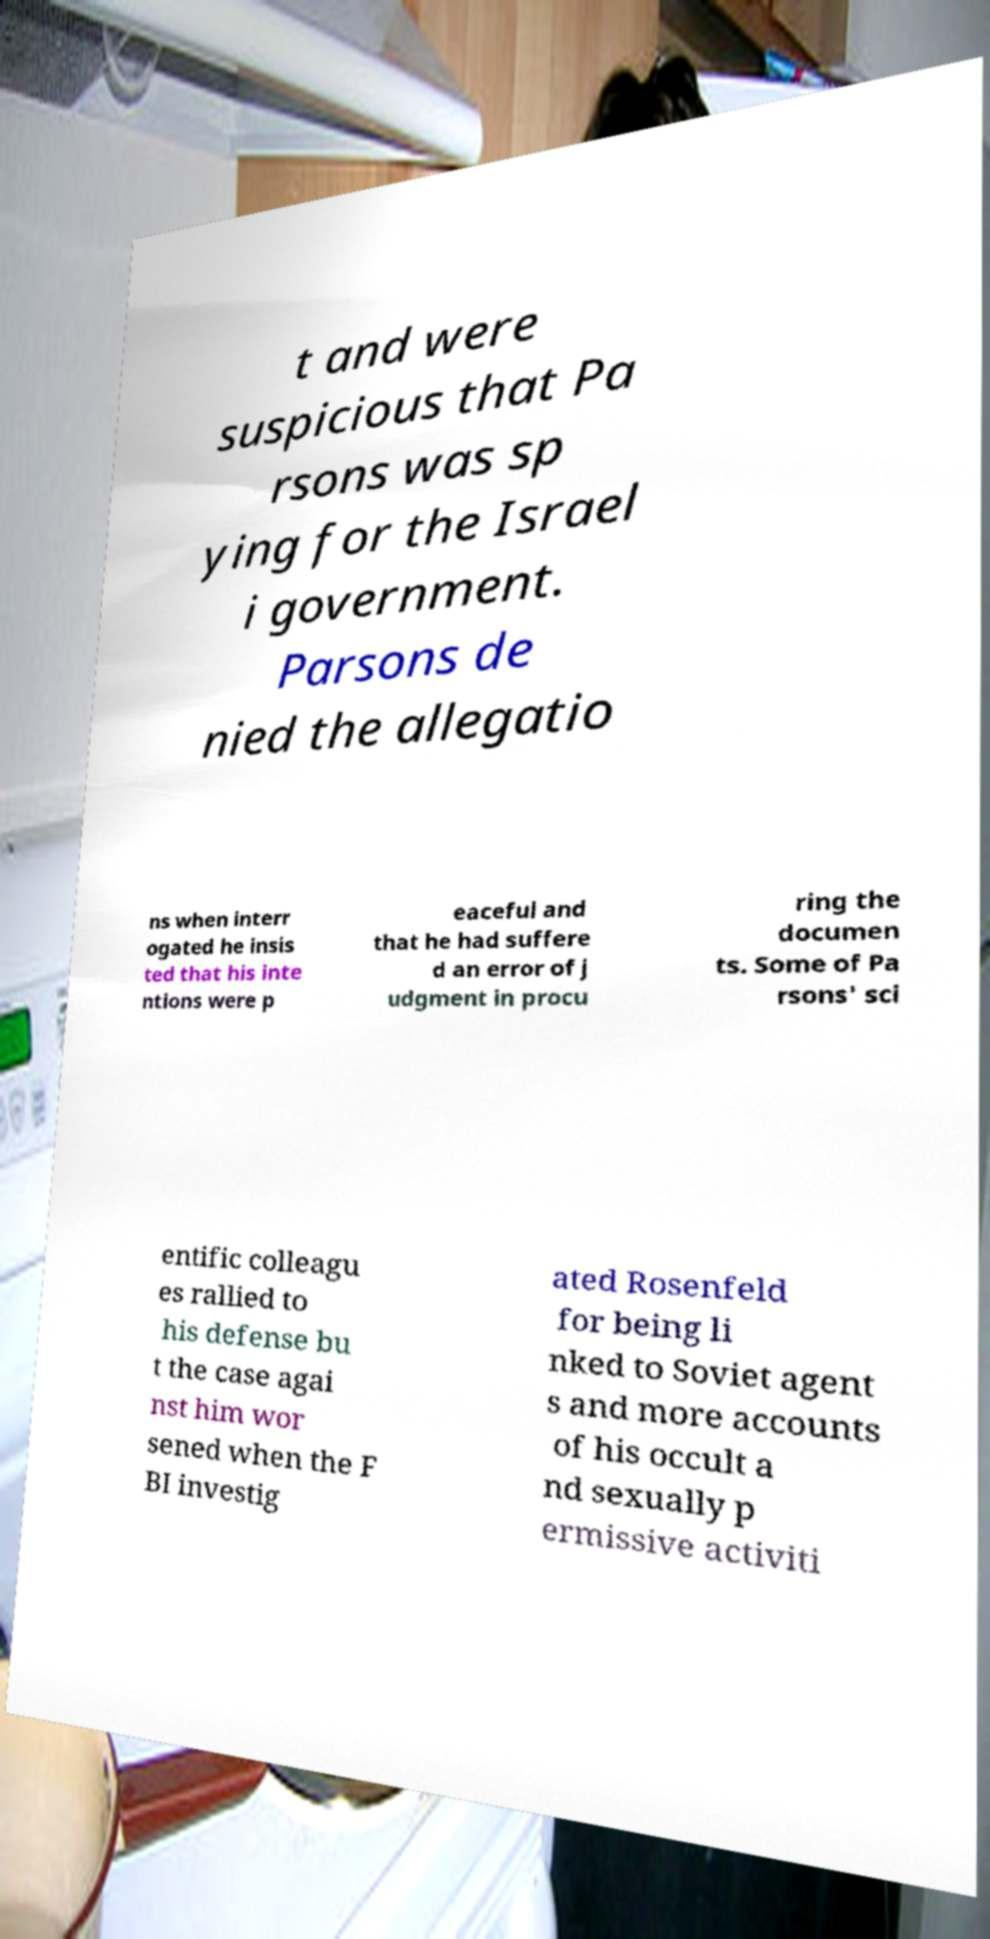Can you accurately transcribe the text from the provided image for me? t and were suspicious that Pa rsons was sp ying for the Israel i government. Parsons de nied the allegatio ns when interr ogated he insis ted that his inte ntions were p eaceful and that he had suffere d an error of j udgment in procu ring the documen ts. Some of Pa rsons' sci entific colleagu es rallied to his defense bu t the case agai nst him wor sened when the F BI investig ated Rosenfeld for being li nked to Soviet agent s and more accounts of his occult a nd sexually p ermissive activiti 